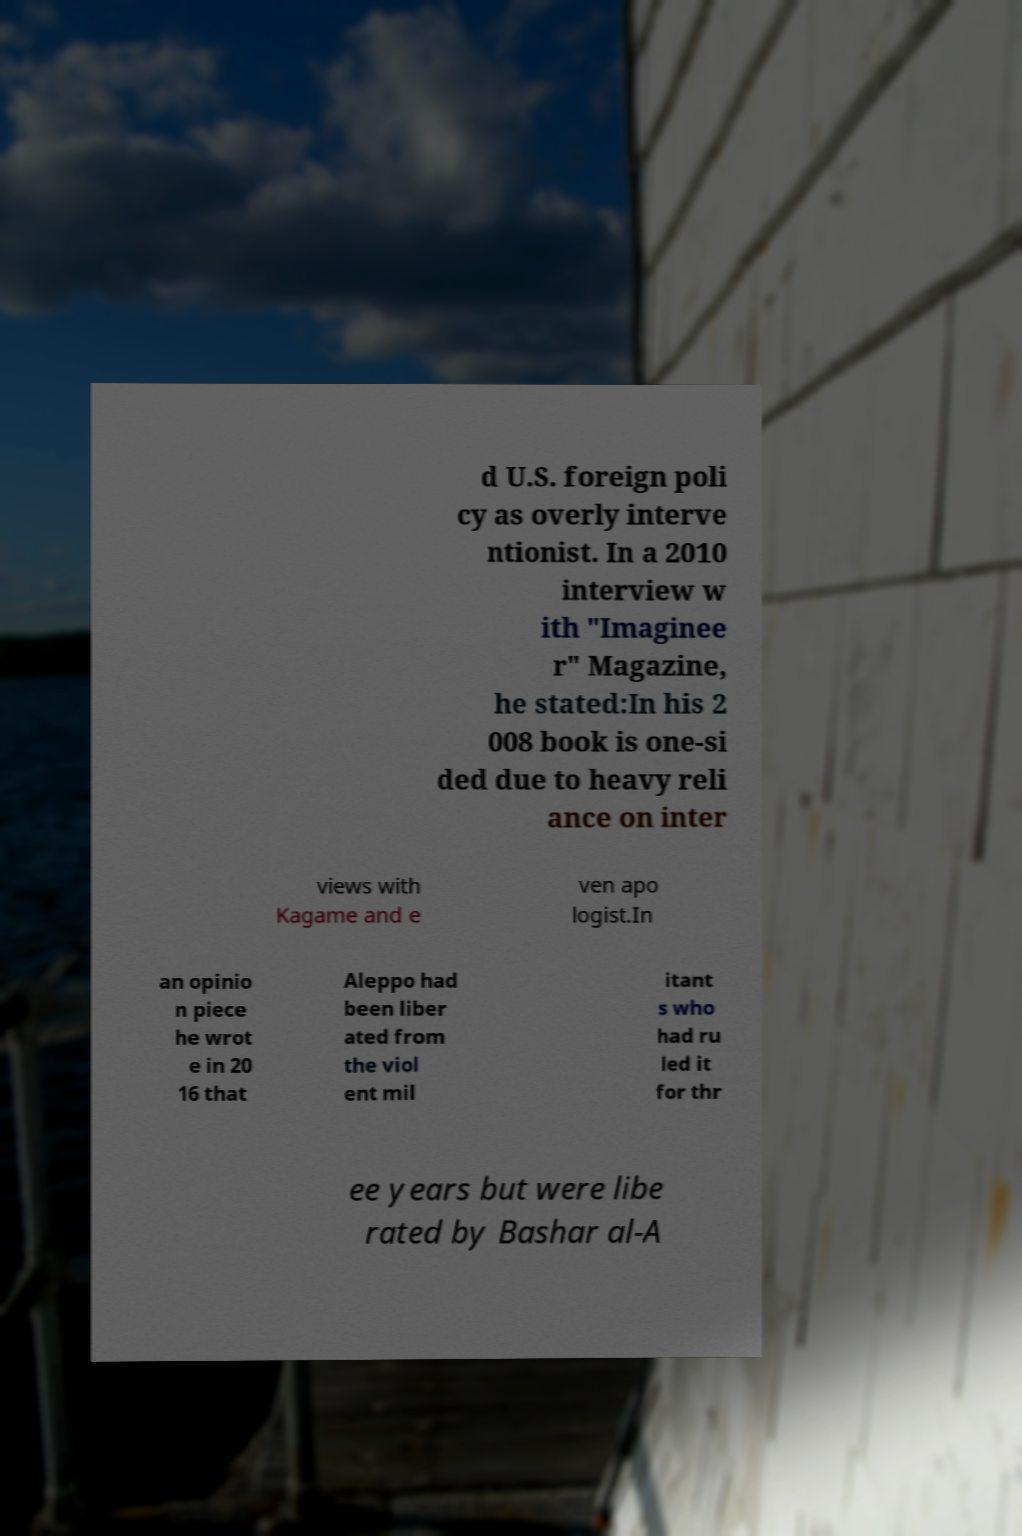Can you accurately transcribe the text from the provided image for me? d U.S. foreign poli cy as overly interve ntionist. In a 2010 interview w ith "Imaginee r" Magazine, he stated:In his 2 008 book is one-si ded due to heavy reli ance on inter views with Kagame and e ven apo logist.In an opinio n piece he wrot e in 20 16 that Aleppo had been liber ated from the viol ent mil itant s who had ru led it for thr ee years but were libe rated by Bashar al-A 